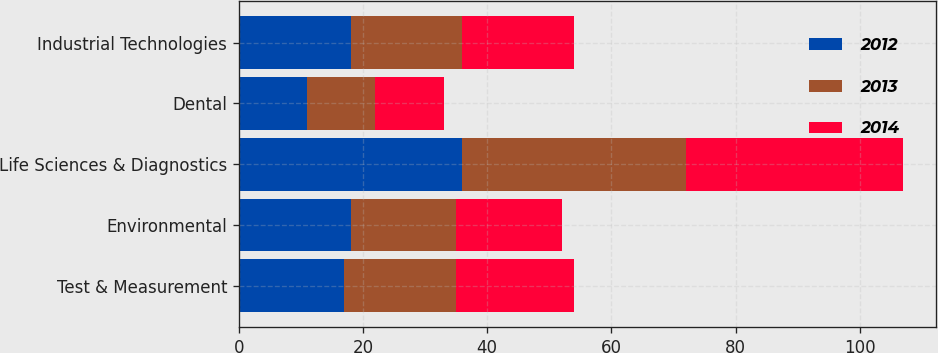<chart> <loc_0><loc_0><loc_500><loc_500><stacked_bar_chart><ecel><fcel>Test & Measurement<fcel>Environmental<fcel>Life Sciences & Diagnostics<fcel>Dental<fcel>Industrial Technologies<nl><fcel>2012<fcel>17<fcel>18<fcel>36<fcel>11<fcel>18<nl><fcel>2013<fcel>18<fcel>17<fcel>36<fcel>11<fcel>18<nl><fcel>2014<fcel>19<fcel>17<fcel>35<fcel>11<fcel>18<nl></chart> 